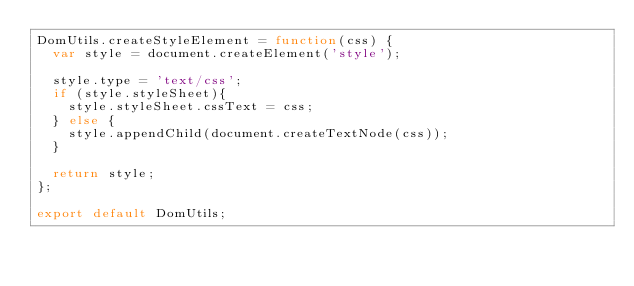Convert code to text. <code><loc_0><loc_0><loc_500><loc_500><_JavaScript_>DomUtils.createStyleElement = function(css) {
  var style = document.createElement('style');

  style.type = 'text/css';
  if (style.styleSheet){
    style.styleSheet.cssText = css;
  } else {
    style.appendChild(document.createTextNode(css));
  }

  return style;
};

export default DomUtils;
</code> 